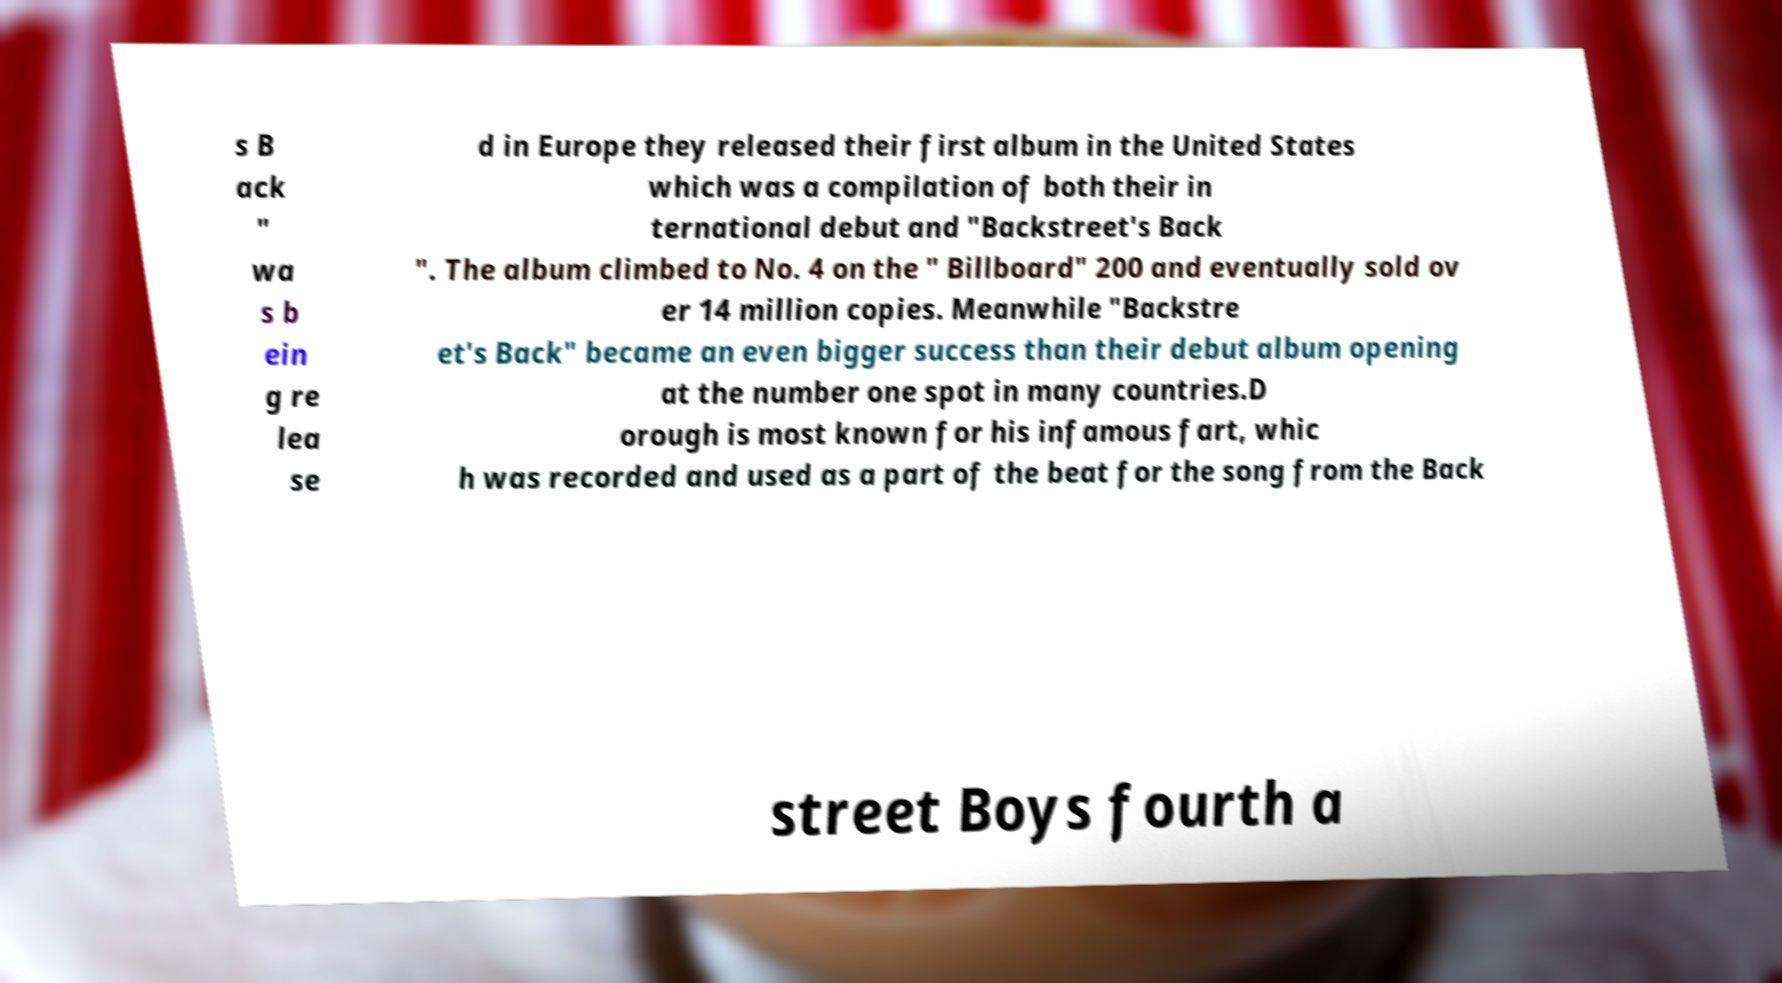Can you read and provide the text displayed in the image?This photo seems to have some interesting text. Can you extract and type it out for me? s B ack " wa s b ein g re lea se d in Europe they released their first album in the United States which was a compilation of both their in ternational debut and "Backstreet's Back ". The album climbed to No. 4 on the " Billboard" 200 and eventually sold ov er 14 million copies. Meanwhile "Backstre et's Back" became an even bigger success than their debut album opening at the number one spot in many countries.D orough is most known for his infamous fart, whic h was recorded and used as a part of the beat for the song from the Back street Boys fourth a 